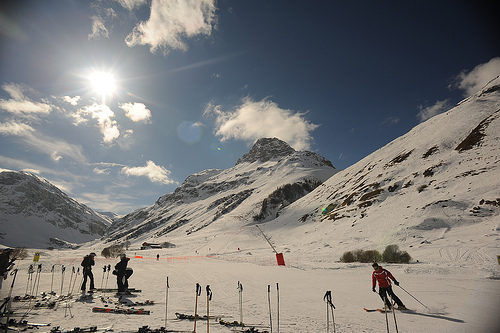Which side is the fence on, the right or the left? The orange fence is situated to the left side of the image, setting a clear boundary along the skiing area. 